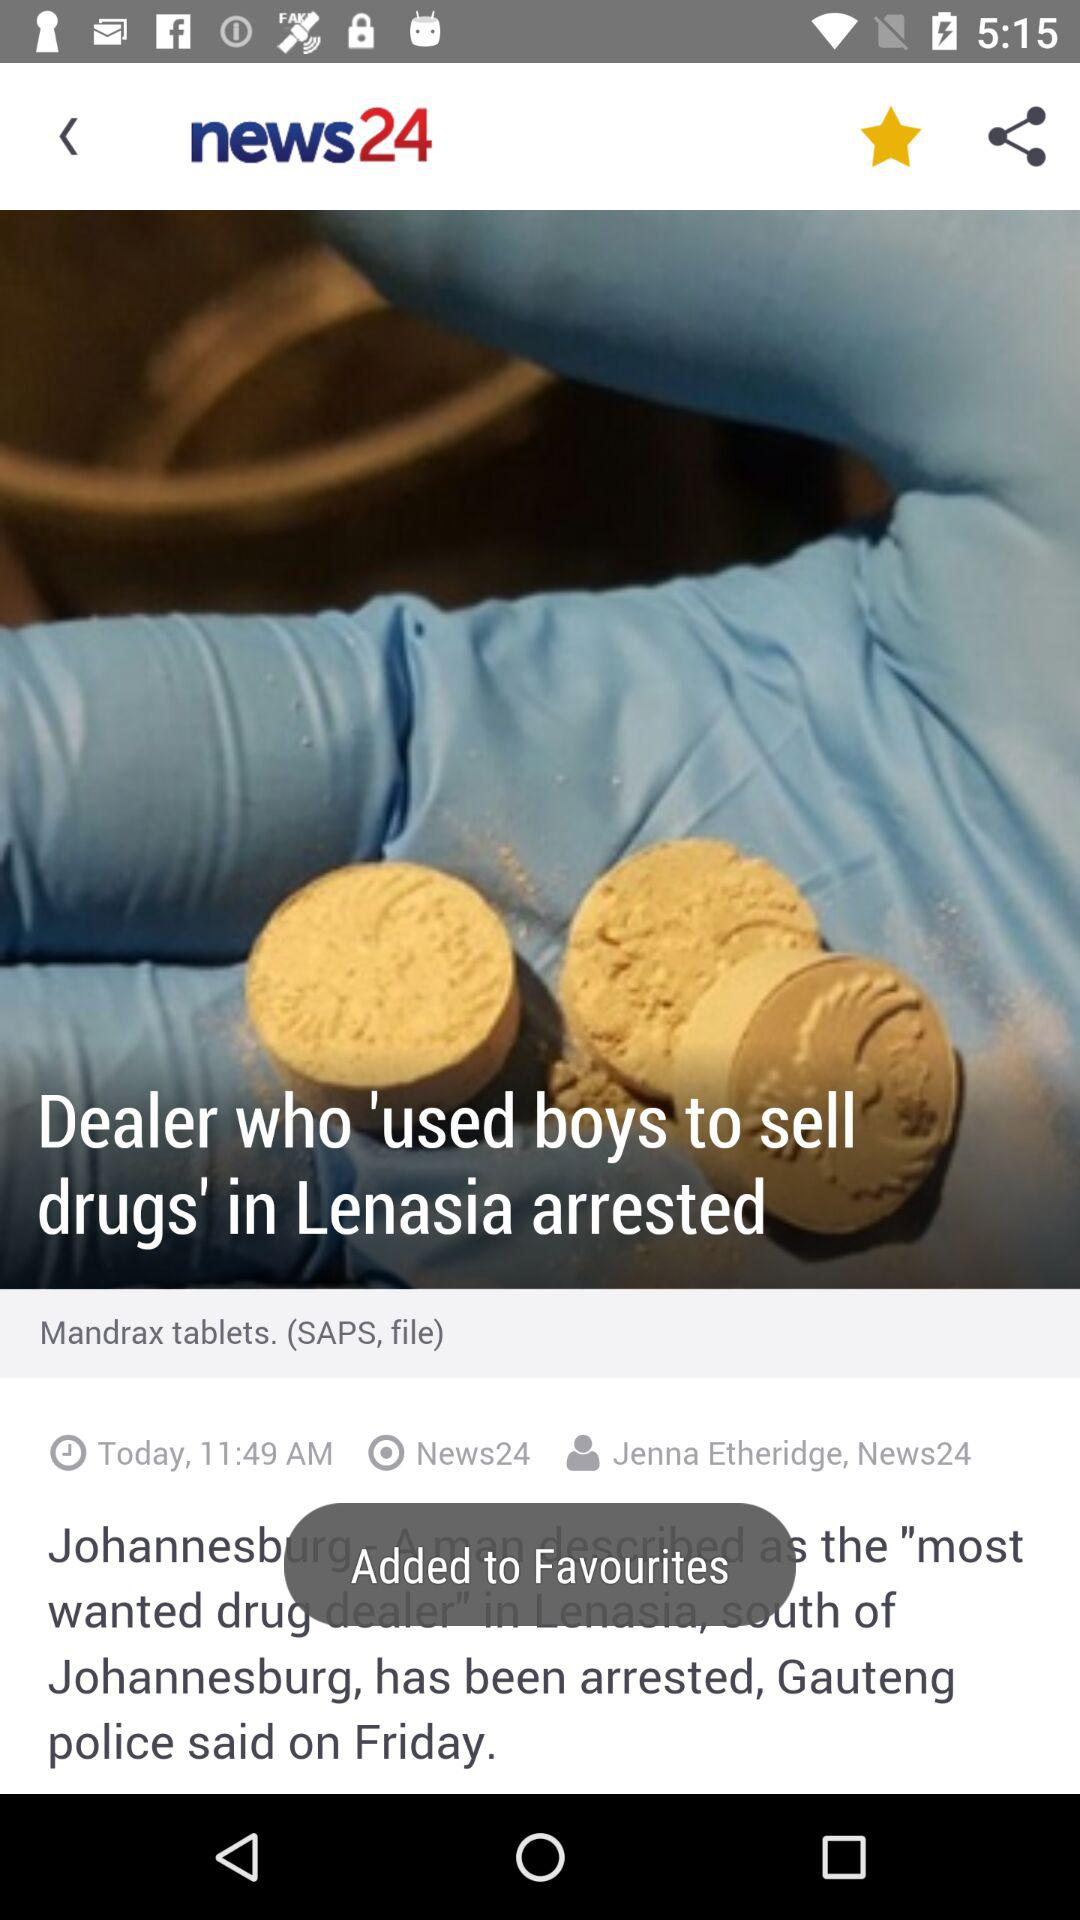What is the time of the news? The time is 11:49 AM. 